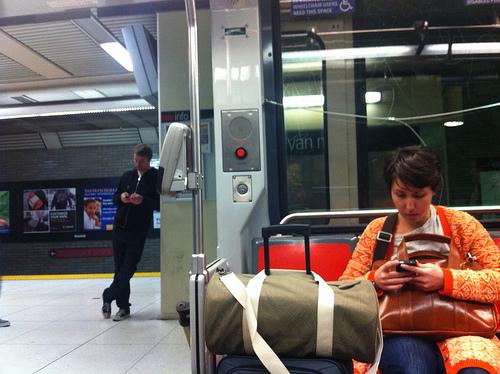Spot the woman sitting down and describe her actions. The woman seated in a chair is looking at her mobile phone, possibly checking messages, scrolling through social media or browsing the internet. Tell a story about people waiting for their transportation. Passengers at the station, possibly an airport or train station, are waiting for their transportation, carrying their bags and engaging with their cell phones to pass the time, possibly texting friends or browsing social media. What is the primary focus of this image and what activity is taking place? The main focus of this image is people waiting at a station, with many of them using their cell phones or holding their bags. Explain the environment where the people are gathered and their primary activities. The people are in a station, possibly an airport or train station, waiting for their transportation and mostly engaged with their cell phones or holding their personal belongings. Mention a fashion item in the image and describe the person who is wearing it. A man is wearing a black jacket, possibly indicating a casual or semi-formal style. Give a brief description of the woman wearing an orange shirt and what she has in her possession. The woman is wearing an orange long sleeve shirt and holding a large brown leather pocket book, with a mobile phone possibly in use. Which item in the scene could be used for communication purposes and where is it located? A grey communication device, possibly a speaker, is mounted on a pillar in the vicinity of the people. For a product advertisement, feature one of the bags in the image and describe its appearance. Introducing the perfect travel companion: our olive duffle bag with white straps. Stylish, durable, and spacious enough to fit all your essential belongings. Identify a distinctive item present in the scene and explain where it is located. A blue handicap sign is present in the image, located above the woman wearing an orange shirt. Describe the actions of the man leaning against the wall. The man leaning against the wall is preoccupied with his cell phone, possibly texting or using an app. 